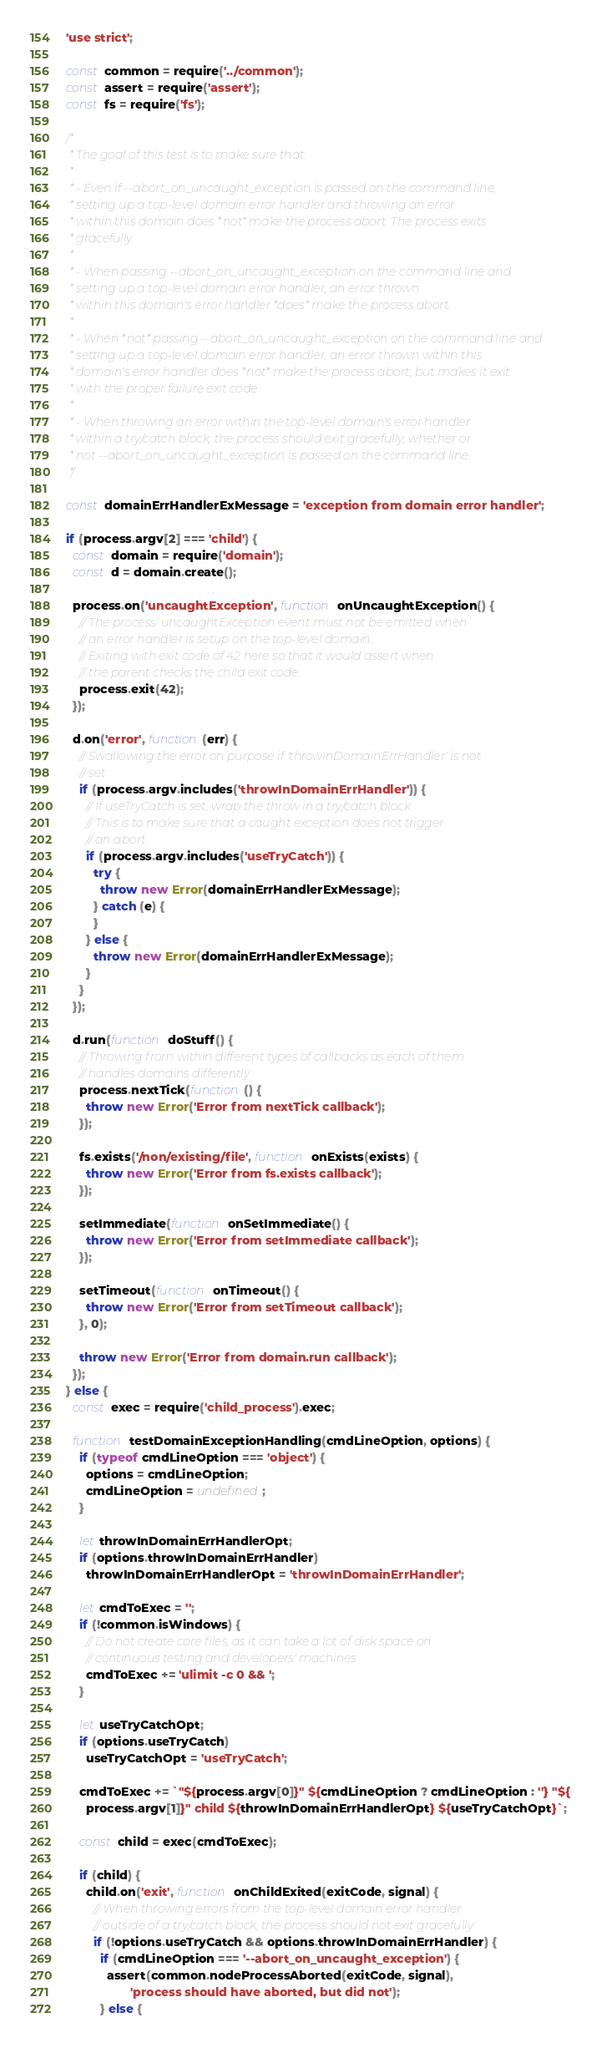<code> <loc_0><loc_0><loc_500><loc_500><_JavaScript_>'use strict';

const common = require('../common');
const assert = require('assert');
const fs = require('fs');

/*
 * The goal of this test is to make sure that:
 *
 * - Even if --abort_on_uncaught_exception is passed on the command line,
 * setting up a top-level domain error handler and throwing an error
 * within this domain does *not* make the process abort. The process exits
 * gracefully.
 *
 * - When passing --abort_on_uncaught_exception on the command line and
 * setting up a top-level domain error handler, an error thrown
 * within this domain's error handler *does* make the process abort.
 *
 * - When *not* passing --abort_on_uncaught_exception on the command line and
 * setting up a top-level domain error handler, an error thrown within this
 * domain's error handler does *not* make the process abort, but makes it exit
 * with the proper failure exit code.
 *
 * - When throwing an error within the top-level domain's error handler
 * within a try/catch block, the process should exit gracefully, whether or
 * not --abort_on_uncaught_exception is passed on the command line.
 */

const domainErrHandlerExMessage = 'exception from domain error handler';

if (process.argv[2] === 'child') {
  const domain = require('domain');
  const d = domain.create();

  process.on('uncaughtException', function onUncaughtException() {
    // The process' uncaughtException event must not be emitted when
    // an error handler is setup on the top-level domain.
    // Exiting with exit code of 42 here so that it would assert when
    // the parent checks the child exit code.
    process.exit(42);
  });

  d.on('error', function(err) {
    // Swallowing the error on purpose if 'throwInDomainErrHandler' is not
    // set
    if (process.argv.includes('throwInDomainErrHandler')) {
      // If useTryCatch is set, wrap the throw in a try/catch block.
      // This is to make sure that a caught exception does not trigger
      // an abort.
      if (process.argv.includes('useTryCatch')) {
        try {
          throw new Error(domainErrHandlerExMessage);
        } catch (e) {
        }
      } else {
        throw new Error(domainErrHandlerExMessage);
      }
    }
  });

  d.run(function doStuff() {
    // Throwing from within different types of callbacks as each of them
    // handles domains differently
    process.nextTick(function() {
      throw new Error('Error from nextTick callback');
    });

    fs.exists('/non/existing/file', function onExists(exists) {
      throw new Error('Error from fs.exists callback');
    });

    setImmediate(function onSetImmediate() {
      throw new Error('Error from setImmediate callback');
    });

    setTimeout(function onTimeout() {
      throw new Error('Error from setTimeout callback');
    }, 0);

    throw new Error('Error from domain.run callback');
  });
} else {
  const exec = require('child_process').exec;

  function testDomainExceptionHandling(cmdLineOption, options) {
    if (typeof cmdLineOption === 'object') {
      options = cmdLineOption;
      cmdLineOption = undefined;
    }

    let throwInDomainErrHandlerOpt;
    if (options.throwInDomainErrHandler)
      throwInDomainErrHandlerOpt = 'throwInDomainErrHandler';

    let cmdToExec = '';
    if (!common.isWindows) {
      // Do not create core files, as it can take a lot of disk space on
      // continuous testing and developers' machines
      cmdToExec += 'ulimit -c 0 && ';
    }

    let useTryCatchOpt;
    if (options.useTryCatch)
      useTryCatchOpt = 'useTryCatch';

    cmdToExec += `"${process.argv[0]}" ${cmdLineOption ? cmdLineOption : ''} "${
      process.argv[1]}" child ${throwInDomainErrHandlerOpt} ${useTryCatchOpt}`;

    const child = exec(cmdToExec);

    if (child) {
      child.on('exit', function onChildExited(exitCode, signal) {
        // When throwing errors from the top-level domain error handler
        // outside of a try/catch block, the process should not exit gracefully
        if (!options.useTryCatch && options.throwInDomainErrHandler) {
          if (cmdLineOption === '--abort_on_uncaught_exception') {
            assert(common.nodeProcessAborted(exitCode, signal),
                   'process should have aborted, but did not');
          } else {</code> 